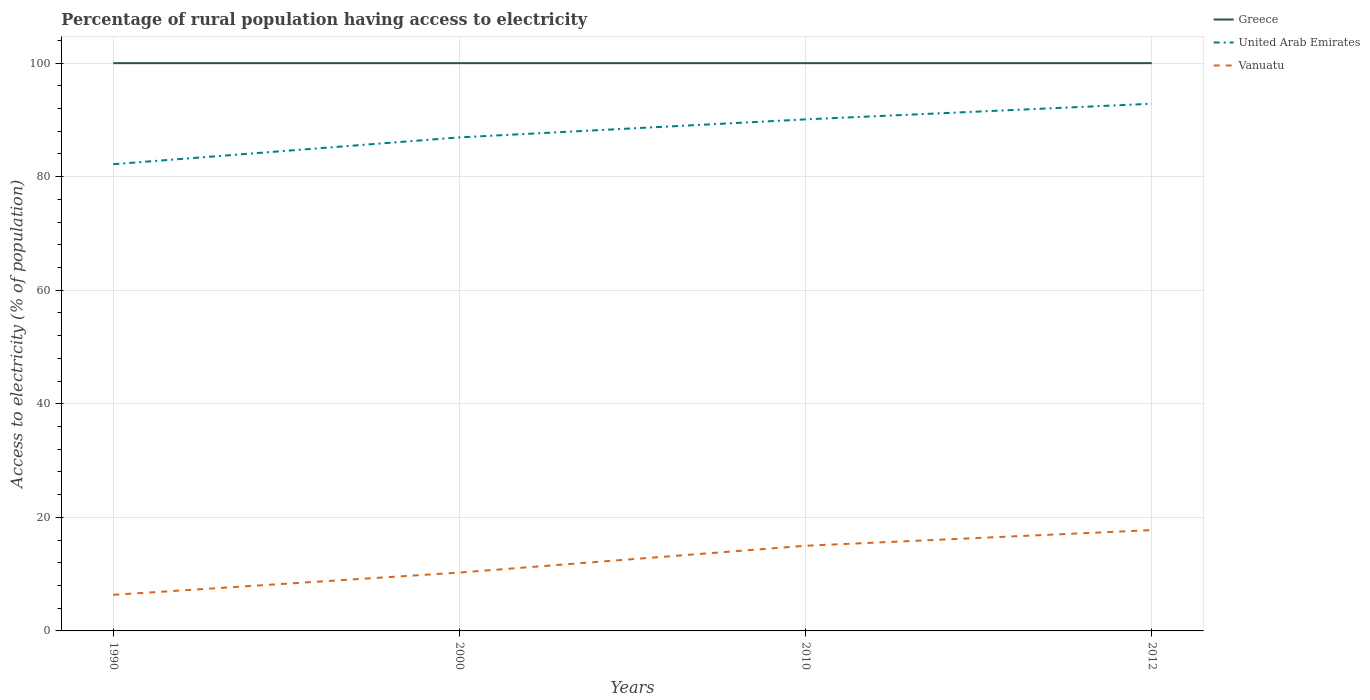Does the line corresponding to Vanuatu intersect with the line corresponding to United Arab Emirates?
Your response must be concise. No. Across all years, what is the maximum percentage of rural population having access to electricity in Greece?
Keep it short and to the point. 100. In which year was the percentage of rural population having access to electricity in United Arab Emirates maximum?
Keep it short and to the point. 1990. What is the total percentage of rural population having access to electricity in Vanuatu in the graph?
Provide a succinct answer. -8.64. What is the difference between the highest and the second highest percentage of rural population having access to electricity in Vanuatu?
Offer a terse response. 11.39. What is the difference between the highest and the lowest percentage of rural population having access to electricity in Vanuatu?
Ensure brevity in your answer.  2. How many years are there in the graph?
Make the answer very short. 4. Are the values on the major ticks of Y-axis written in scientific E-notation?
Ensure brevity in your answer.  No. Does the graph contain any zero values?
Offer a very short reply. No. How are the legend labels stacked?
Provide a short and direct response. Vertical. What is the title of the graph?
Make the answer very short. Percentage of rural population having access to electricity. Does "St. Vincent and the Grenadines" appear as one of the legend labels in the graph?
Offer a very short reply. No. What is the label or title of the X-axis?
Give a very brief answer. Years. What is the label or title of the Y-axis?
Provide a succinct answer. Access to electricity (% of population). What is the Access to electricity (% of population) of Greece in 1990?
Your answer should be compact. 100. What is the Access to electricity (% of population) of United Arab Emirates in 1990?
Ensure brevity in your answer.  82.2. What is the Access to electricity (% of population) in Vanuatu in 1990?
Make the answer very short. 6.36. What is the Access to electricity (% of population) in United Arab Emirates in 2000?
Your answer should be very brief. 86.93. What is the Access to electricity (% of population) in Vanuatu in 2000?
Ensure brevity in your answer.  10.28. What is the Access to electricity (% of population) of Greece in 2010?
Provide a succinct answer. 100. What is the Access to electricity (% of population) in United Arab Emirates in 2010?
Give a very brief answer. 90.1. What is the Access to electricity (% of population) of Vanuatu in 2010?
Provide a short and direct response. 15. What is the Access to electricity (% of population) of United Arab Emirates in 2012?
Give a very brief answer. 92.85. What is the Access to electricity (% of population) in Vanuatu in 2012?
Provide a succinct answer. 17.75. Across all years, what is the maximum Access to electricity (% of population) of Greece?
Provide a succinct answer. 100. Across all years, what is the maximum Access to electricity (% of population) of United Arab Emirates?
Make the answer very short. 92.85. Across all years, what is the maximum Access to electricity (% of population) in Vanuatu?
Ensure brevity in your answer.  17.75. Across all years, what is the minimum Access to electricity (% of population) in Greece?
Ensure brevity in your answer.  100. Across all years, what is the minimum Access to electricity (% of population) of United Arab Emirates?
Offer a terse response. 82.2. Across all years, what is the minimum Access to electricity (% of population) in Vanuatu?
Provide a short and direct response. 6.36. What is the total Access to electricity (% of population) in Greece in the graph?
Provide a succinct answer. 400. What is the total Access to electricity (% of population) of United Arab Emirates in the graph?
Your answer should be very brief. 352.08. What is the total Access to electricity (% of population) in Vanuatu in the graph?
Provide a succinct answer. 49.4. What is the difference between the Access to electricity (% of population) of United Arab Emirates in 1990 and that in 2000?
Provide a short and direct response. -4.72. What is the difference between the Access to electricity (% of population) of Vanuatu in 1990 and that in 2000?
Your answer should be compact. -3.92. What is the difference between the Access to electricity (% of population) in United Arab Emirates in 1990 and that in 2010?
Make the answer very short. -7.9. What is the difference between the Access to electricity (% of population) of Vanuatu in 1990 and that in 2010?
Your response must be concise. -8.64. What is the difference between the Access to electricity (% of population) of United Arab Emirates in 1990 and that in 2012?
Your answer should be compact. -10.65. What is the difference between the Access to electricity (% of population) in Vanuatu in 1990 and that in 2012?
Offer a terse response. -11.39. What is the difference between the Access to electricity (% of population) of Greece in 2000 and that in 2010?
Ensure brevity in your answer.  0. What is the difference between the Access to electricity (% of population) in United Arab Emirates in 2000 and that in 2010?
Your answer should be very brief. -3.17. What is the difference between the Access to electricity (% of population) in Vanuatu in 2000 and that in 2010?
Provide a succinct answer. -4.72. What is the difference between the Access to electricity (% of population) of Greece in 2000 and that in 2012?
Provide a short and direct response. 0. What is the difference between the Access to electricity (% of population) in United Arab Emirates in 2000 and that in 2012?
Your answer should be very brief. -5.93. What is the difference between the Access to electricity (% of population) in Vanuatu in 2000 and that in 2012?
Give a very brief answer. -7.47. What is the difference between the Access to electricity (% of population) in United Arab Emirates in 2010 and that in 2012?
Offer a terse response. -2.75. What is the difference between the Access to electricity (% of population) of Vanuatu in 2010 and that in 2012?
Provide a succinct answer. -2.75. What is the difference between the Access to electricity (% of population) of Greece in 1990 and the Access to electricity (% of population) of United Arab Emirates in 2000?
Your response must be concise. 13.07. What is the difference between the Access to electricity (% of population) in Greece in 1990 and the Access to electricity (% of population) in Vanuatu in 2000?
Offer a very short reply. 89.72. What is the difference between the Access to electricity (% of population) of United Arab Emirates in 1990 and the Access to electricity (% of population) of Vanuatu in 2000?
Your response must be concise. 71.92. What is the difference between the Access to electricity (% of population) of Greece in 1990 and the Access to electricity (% of population) of United Arab Emirates in 2010?
Your response must be concise. 9.9. What is the difference between the Access to electricity (% of population) in Greece in 1990 and the Access to electricity (% of population) in Vanuatu in 2010?
Provide a short and direct response. 85. What is the difference between the Access to electricity (% of population) in United Arab Emirates in 1990 and the Access to electricity (% of population) in Vanuatu in 2010?
Provide a short and direct response. 67.2. What is the difference between the Access to electricity (% of population) of Greece in 1990 and the Access to electricity (% of population) of United Arab Emirates in 2012?
Your response must be concise. 7.15. What is the difference between the Access to electricity (% of population) in Greece in 1990 and the Access to electricity (% of population) in Vanuatu in 2012?
Give a very brief answer. 82.25. What is the difference between the Access to electricity (% of population) in United Arab Emirates in 1990 and the Access to electricity (% of population) in Vanuatu in 2012?
Make the answer very short. 64.45. What is the difference between the Access to electricity (% of population) of United Arab Emirates in 2000 and the Access to electricity (% of population) of Vanuatu in 2010?
Your answer should be very brief. 71.93. What is the difference between the Access to electricity (% of population) of Greece in 2000 and the Access to electricity (% of population) of United Arab Emirates in 2012?
Offer a very short reply. 7.15. What is the difference between the Access to electricity (% of population) in Greece in 2000 and the Access to electricity (% of population) in Vanuatu in 2012?
Keep it short and to the point. 82.25. What is the difference between the Access to electricity (% of population) of United Arab Emirates in 2000 and the Access to electricity (% of population) of Vanuatu in 2012?
Your answer should be compact. 69.17. What is the difference between the Access to electricity (% of population) of Greece in 2010 and the Access to electricity (% of population) of United Arab Emirates in 2012?
Keep it short and to the point. 7.15. What is the difference between the Access to electricity (% of population) of Greece in 2010 and the Access to electricity (% of population) of Vanuatu in 2012?
Your answer should be compact. 82.25. What is the difference between the Access to electricity (% of population) of United Arab Emirates in 2010 and the Access to electricity (% of population) of Vanuatu in 2012?
Provide a short and direct response. 72.35. What is the average Access to electricity (% of population) of Greece per year?
Offer a very short reply. 100. What is the average Access to electricity (% of population) in United Arab Emirates per year?
Offer a very short reply. 88.02. What is the average Access to electricity (% of population) in Vanuatu per year?
Keep it short and to the point. 12.35. In the year 1990, what is the difference between the Access to electricity (% of population) of Greece and Access to electricity (% of population) of United Arab Emirates?
Provide a short and direct response. 17.8. In the year 1990, what is the difference between the Access to electricity (% of population) of Greece and Access to electricity (% of population) of Vanuatu?
Offer a terse response. 93.64. In the year 1990, what is the difference between the Access to electricity (% of population) in United Arab Emirates and Access to electricity (% of population) in Vanuatu?
Give a very brief answer. 75.84. In the year 2000, what is the difference between the Access to electricity (% of population) of Greece and Access to electricity (% of population) of United Arab Emirates?
Offer a very short reply. 13.07. In the year 2000, what is the difference between the Access to electricity (% of population) in Greece and Access to electricity (% of population) in Vanuatu?
Give a very brief answer. 89.72. In the year 2000, what is the difference between the Access to electricity (% of population) of United Arab Emirates and Access to electricity (% of population) of Vanuatu?
Ensure brevity in your answer.  76.65. In the year 2010, what is the difference between the Access to electricity (% of population) of Greece and Access to electricity (% of population) of Vanuatu?
Offer a terse response. 85. In the year 2010, what is the difference between the Access to electricity (% of population) in United Arab Emirates and Access to electricity (% of population) in Vanuatu?
Your response must be concise. 75.1. In the year 2012, what is the difference between the Access to electricity (% of population) of Greece and Access to electricity (% of population) of United Arab Emirates?
Make the answer very short. 7.15. In the year 2012, what is the difference between the Access to electricity (% of population) in Greece and Access to electricity (% of population) in Vanuatu?
Your answer should be very brief. 82.25. In the year 2012, what is the difference between the Access to electricity (% of population) in United Arab Emirates and Access to electricity (% of population) in Vanuatu?
Provide a succinct answer. 75.1. What is the ratio of the Access to electricity (% of population) in Greece in 1990 to that in 2000?
Ensure brevity in your answer.  1. What is the ratio of the Access to electricity (% of population) of United Arab Emirates in 1990 to that in 2000?
Your answer should be compact. 0.95. What is the ratio of the Access to electricity (% of population) of Vanuatu in 1990 to that in 2000?
Your answer should be compact. 0.62. What is the ratio of the Access to electricity (% of population) of Greece in 1990 to that in 2010?
Give a very brief answer. 1. What is the ratio of the Access to electricity (% of population) in United Arab Emirates in 1990 to that in 2010?
Provide a succinct answer. 0.91. What is the ratio of the Access to electricity (% of population) in Vanuatu in 1990 to that in 2010?
Make the answer very short. 0.42. What is the ratio of the Access to electricity (% of population) in Greece in 1990 to that in 2012?
Offer a terse response. 1. What is the ratio of the Access to electricity (% of population) in United Arab Emirates in 1990 to that in 2012?
Ensure brevity in your answer.  0.89. What is the ratio of the Access to electricity (% of population) in Vanuatu in 1990 to that in 2012?
Ensure brevity in your answer.  0.36. What is the ratio of the Access to electricity (% of population) of United Arab Emirates in 2000 to that in 2010?
Keep it short and to the point. 0.96. What is the ratio of the Access to electricity (% of population) in Vanuatu in 2000 to that in 2010?
Ensure brevity in your answer.  0.69. What is the ratio of the Access to electricity (% of population) of Greece in 2000 to that in 2012?
Your answer should be very brief. 1. What is the ratio of the Access to electricity (% of population) of United Arab Emirates in 2000 to that in 2012?
Your response must be concise. 0.94. What is the ratio of the Access to electricity (% of population) of Vanuatu in 2000 to that in 2012?
Your answer should be very brief. 0.58. What is the ratio of the Access to electricity (% of population) in United Arab Emirates in 2010 to that in 2012?
Ensure brevity in your answer.  0.97. What is the ratio of the Access to electricity (% of population) in Vanuatu in 2010 to that in 2012?
Give a very brief answer. 0.84. What is the difference between the highest and the second highest Access to electricity (% of population) of Greece?
Ensure brevity in your answer.  0. What is the difference between the highest and the second highest Access to electricity (% of population) in United Arab Emirates?
Provide a short and direct response. 2.75. What is the difference between the highest and the second highest Access to electricity (% of population) in Vanuatu?
Provide a short and direct response. 2.75. What is the difference between the highest and the lowest Access to electricity (% of population) of United Arab Emirates?
Offer a terse response. 10.65. What is the difference between the highest and the lowest Access to electricity (% of population) in Vanuatu?
Your response must be concise. 11.39. 